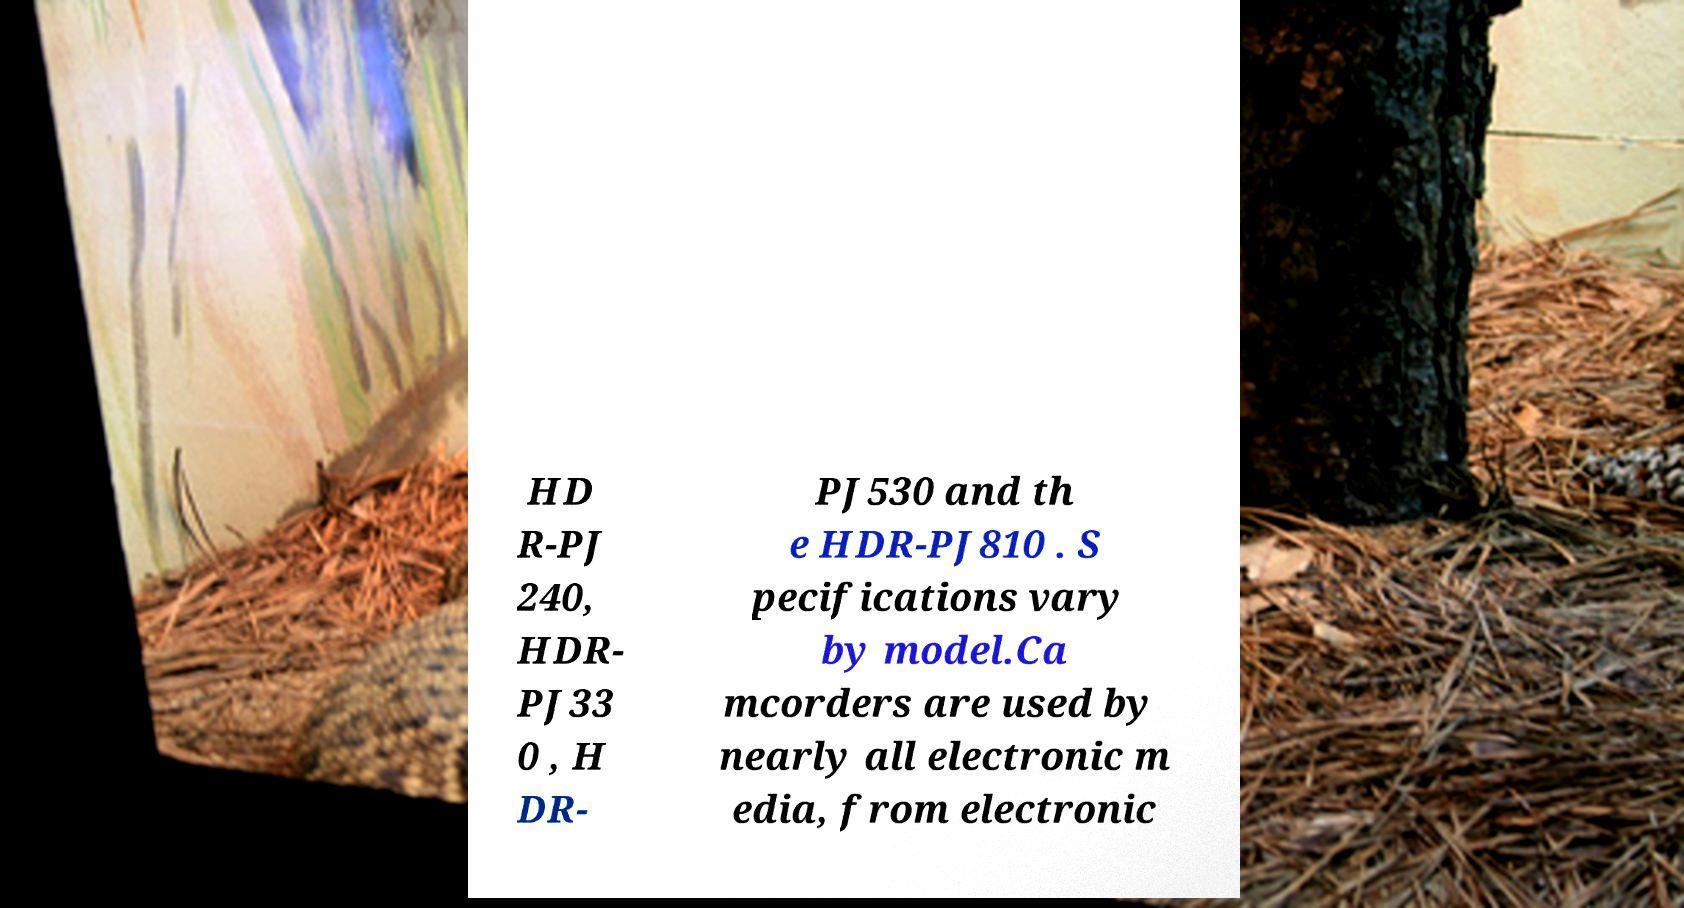Please identify and transcribe the text found in this image. HD R-PJ 240, HDR- PJ33 0 , H DR- PJ530 and th e HDR-PJ810 . S pecifications vary by model.Ca mcorders are used by nearly all electronic m edia, from electronic 